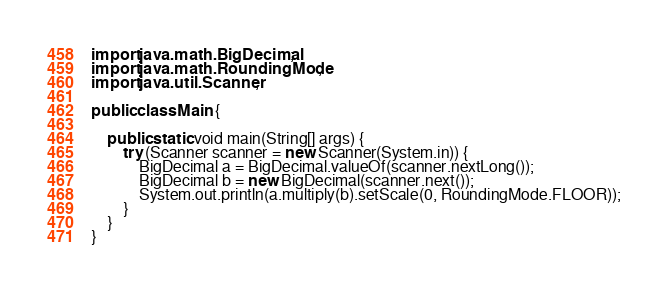Convert code to text. <code><loc_0><loc_0><loc_500><loc_500><_Java_>import java.math.BigDecimal;
import java.math.RoundingMode;
import java.util.Scanner;

public class Main {

	public static void main(String[] args) {
		try (Scanner scanner = new Scanner(System.in)) {
			BigDecimal a = BigDecimal.valueOf(scanner.nextLong());
			BigDecimal b = new BigDecimal(scanner.next());
			System.out.println(a.multiply(b).setScale(0, RoundingMode.FLOOR));
		}
	}
}
</code> 